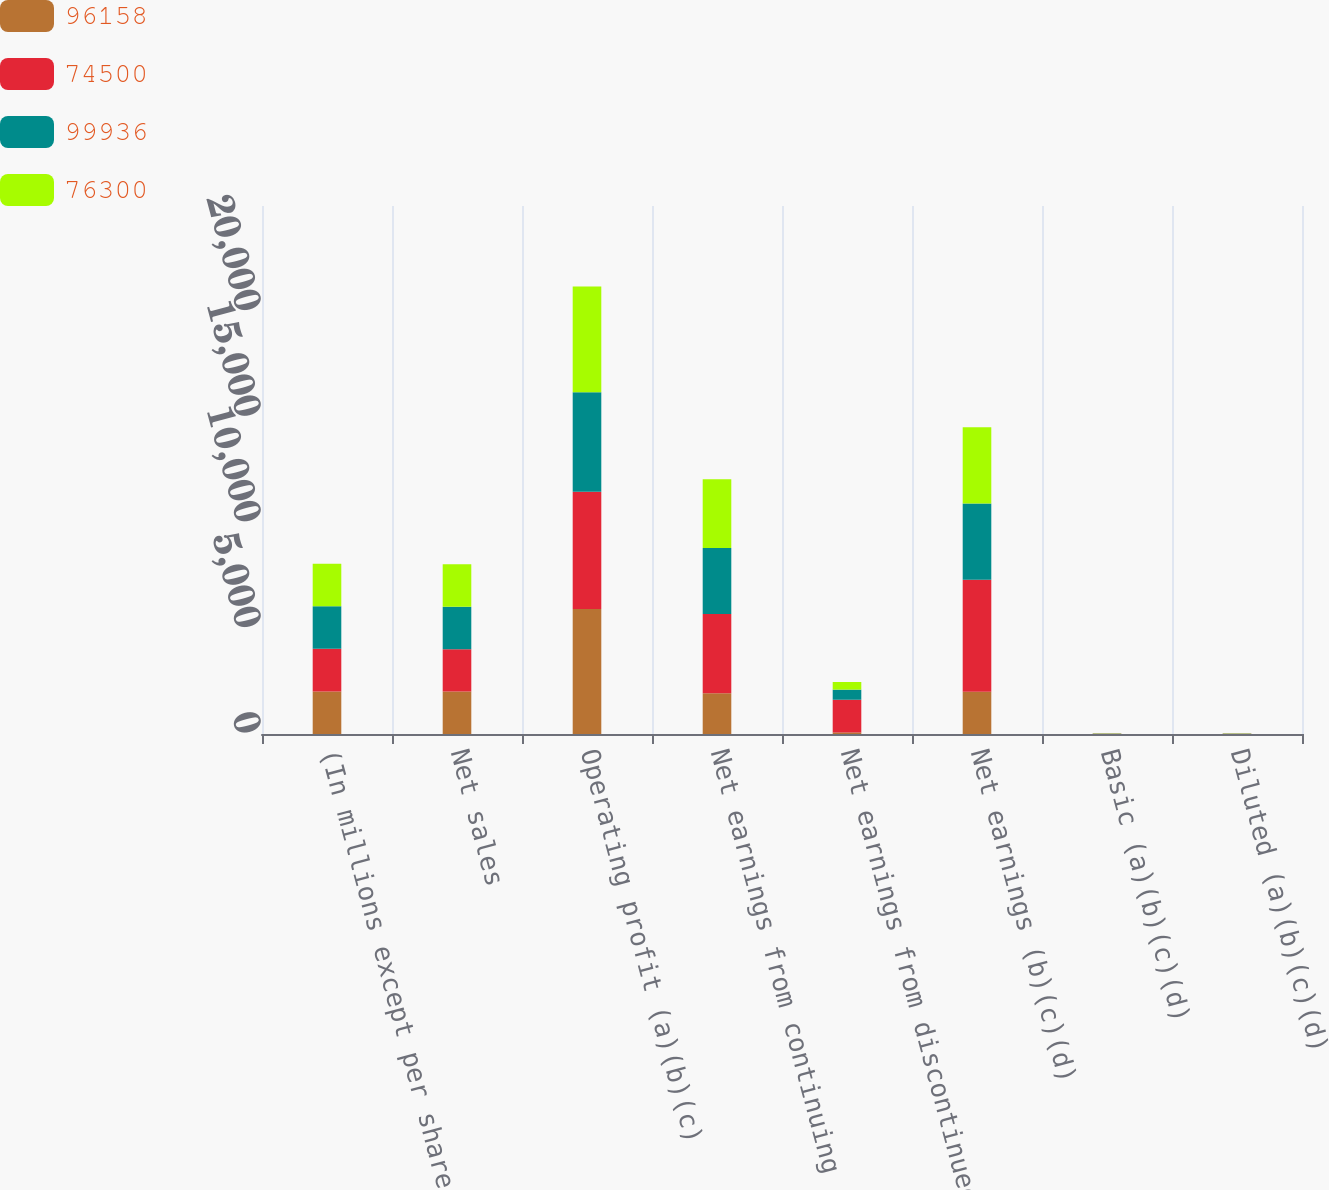<chart> <loc_0><loc_0><loc_500><loc_500><stacked_bar_chart><ecel><fcel>(In millions except per share<fcel>Net sales<fcel>Operating profit (a)(b)(c)<fcel>Net earnings from continuing<fcel>Net earnings from discontinued<fcel>Net earnings (b)(c)(d)<fcel>Basic (a)(b)(c)(d)<fcel>Diluted (a)(b)(c)(d)<nl><fcel>96158<fcel>2017<fcel>2008<fcel>5921<fcel>1929<fcel>73<fcel>2002<fcel>6.7<fcel>6.64<nl><fcel>74500<fcel>2016<fcel>2008<fcel>5549<fcel>3753<fcel>1549<fcel>5302<fcel>12.54<fcel>12.38<nl><fcel>99936<fcel>2015<fcel>2008<fcel>4712<fcel>3126<fcel>479<fcel>3605<fcel>10.07<fcel>9.93<nl><fcel>76300<fcel>2014<fcel>2008<fcel>5012<fcel>3253<fcel>361<fcel>3614<fcel>10.27<fcel>10.09<nl></chart> 